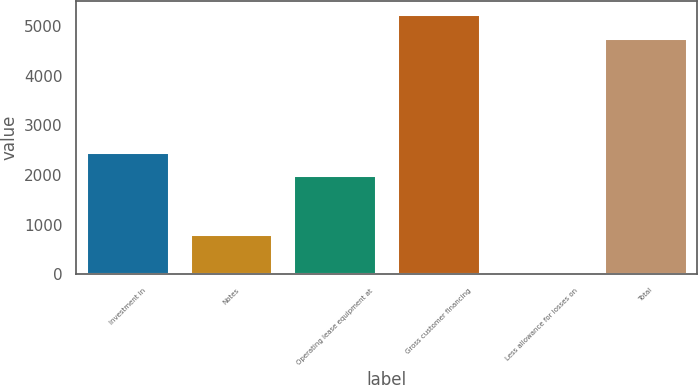Convert chart. <chart><loc_0><loc_0><loc_500><loc_500><bar_chart><fcel>Investment in<fcel>Notes<fcel>Operating lease equipment at<fcel>Gross customer financing<fcel>Less allowance for losses on<fcel>Total<nl><fcel>2468.2<fcel>814<fcel>1991<fcel>5249.2<fcel>70<fcel>4772<nl></chart> 